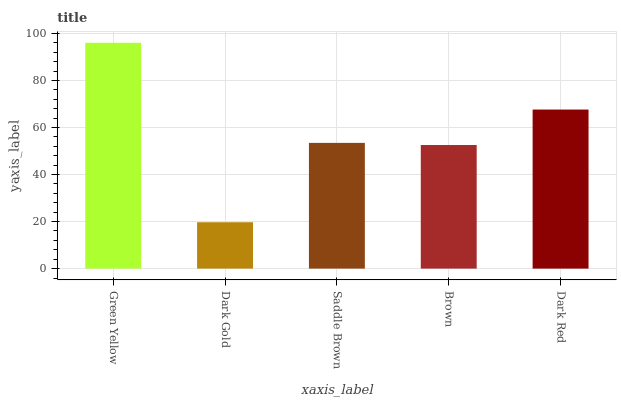Is Dark Gold the minimum?
Answer yes or no. Yes. Is Green Yellow the maximum?
Answer yes or no. Yes. Is Saddle Brown the minimum?
Answer yes or no. No. Is Saddle Brown the maximum?
Answer yes or no. No. Is Saddle Brown greater than Dark Gold?
Answer yes or no. Yes. Is Dark Gold less than Saddle Brown?
Answer yes or no. Yes. Is Dark Gold greater than Saddle Brown?
Answer yes or no. No. Is Saddle Brown less than Dark Gold?
Answer yes or no. No. Is Saddle Brown the high median?
Answer yes or no. Yes. Is Saddle Brown the low median?
Answer yes or no. Yes. Is Brown the high median?
Answer yes or no. No. Is Green Yellow the low median?
Answer yes or no. No. 